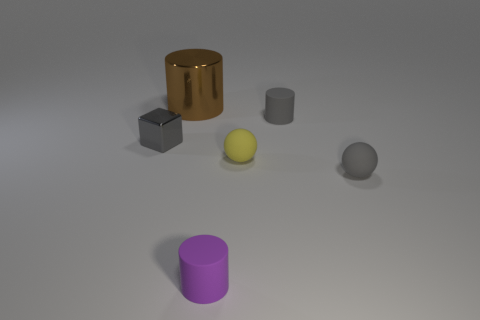There is a matte ball that is the same color as the small cube; what size is it?
Your answer should be compact. Small. Is there any other thing that has the same size as the gray rubber ball?
Your response must be concise. Yes. What color is the small cube that is made of the same material as the brown cylinder?
Ensure brevity in your answer.  Gray. Does the shiny object that is in front of the metallic cylinder have the same color as the small matte cylinder behind the purple cylinder?
Your answer should be compact. Yes. How many cylinders are either large yellow objects or purple objects?
Your answer should be compact. 1. Is the number of cubes left of the tiny gray block the same as the number of small purple things?
Offer a terse response. No. The tiny gray thing that is to the left of the purple rubber object that is right of the shiny thing on the left side of the brown shiny cylinder is made of what material?
Give a very brief answer. Metal. There is a small cylinder that is the same color as the small metallic block; what is its material?
Your answer should be very brief. Rubber. What number of things are either rubber objects that are in front of the yellow thing or tiny red blocks?
Provide a succinct answer. 2. How many things are either small shiny things or small rubber balls in front of the yellow matte sphere?
Offer a very short reply. 2. 